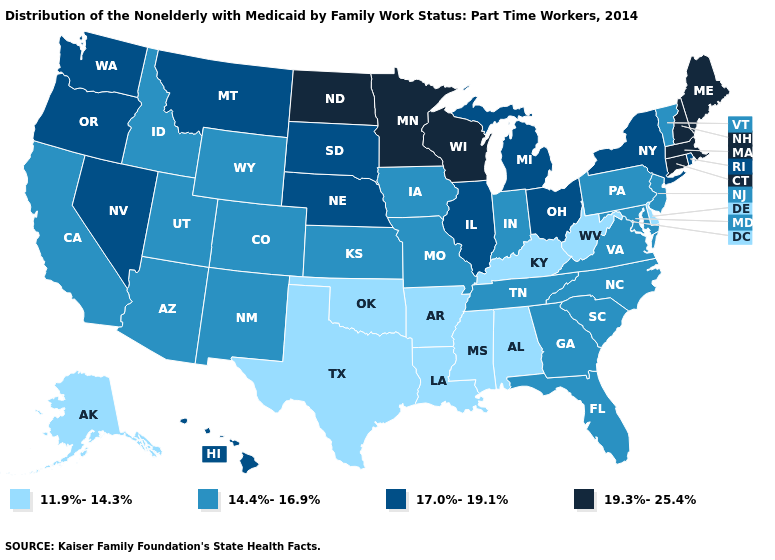What is the value of New Mexico?
Give a very brief answer. 14.4%-16.9%. Does Montana have a lower value than Hawaii?
Concise answer only. No. What is the highest value in the USA?
Concise answer only. 19.3%-25.4%. Does the first symbol in the legend represent the smallest category?
Be succinct. Yes. Does Louisiana have the same value as Maryland?
Short answer required. No. What is the value of Oregon?
Concise answer only. 17.0%-19.1%. What is the highest value in states that border Montana?
Write a very short answer. 19.3%-25.4%. Name the states that have a value in the range 19.3%-25.4%?
Concise answer only. Connecticut, Maine, Massachusetts, Minnesota, New Hampshire, North Dakota, Wisconsin. What is the value of New Mexico?
Concise answer only. 14.4%-16.9%. What is the value of Connecticut?
Concise answer only. 19.3%-25.4%. How many symbols are there in the legend?
Short answer required. 4. What is the value of New York?
Quick response, please. 17.0%-19.1%. What is the value of Michigan?
Write a very short answer. 17.0%-19.1%. Among the states that border New Mexico , does Arizona have the lowest value?
Give a very brief answer. No. 